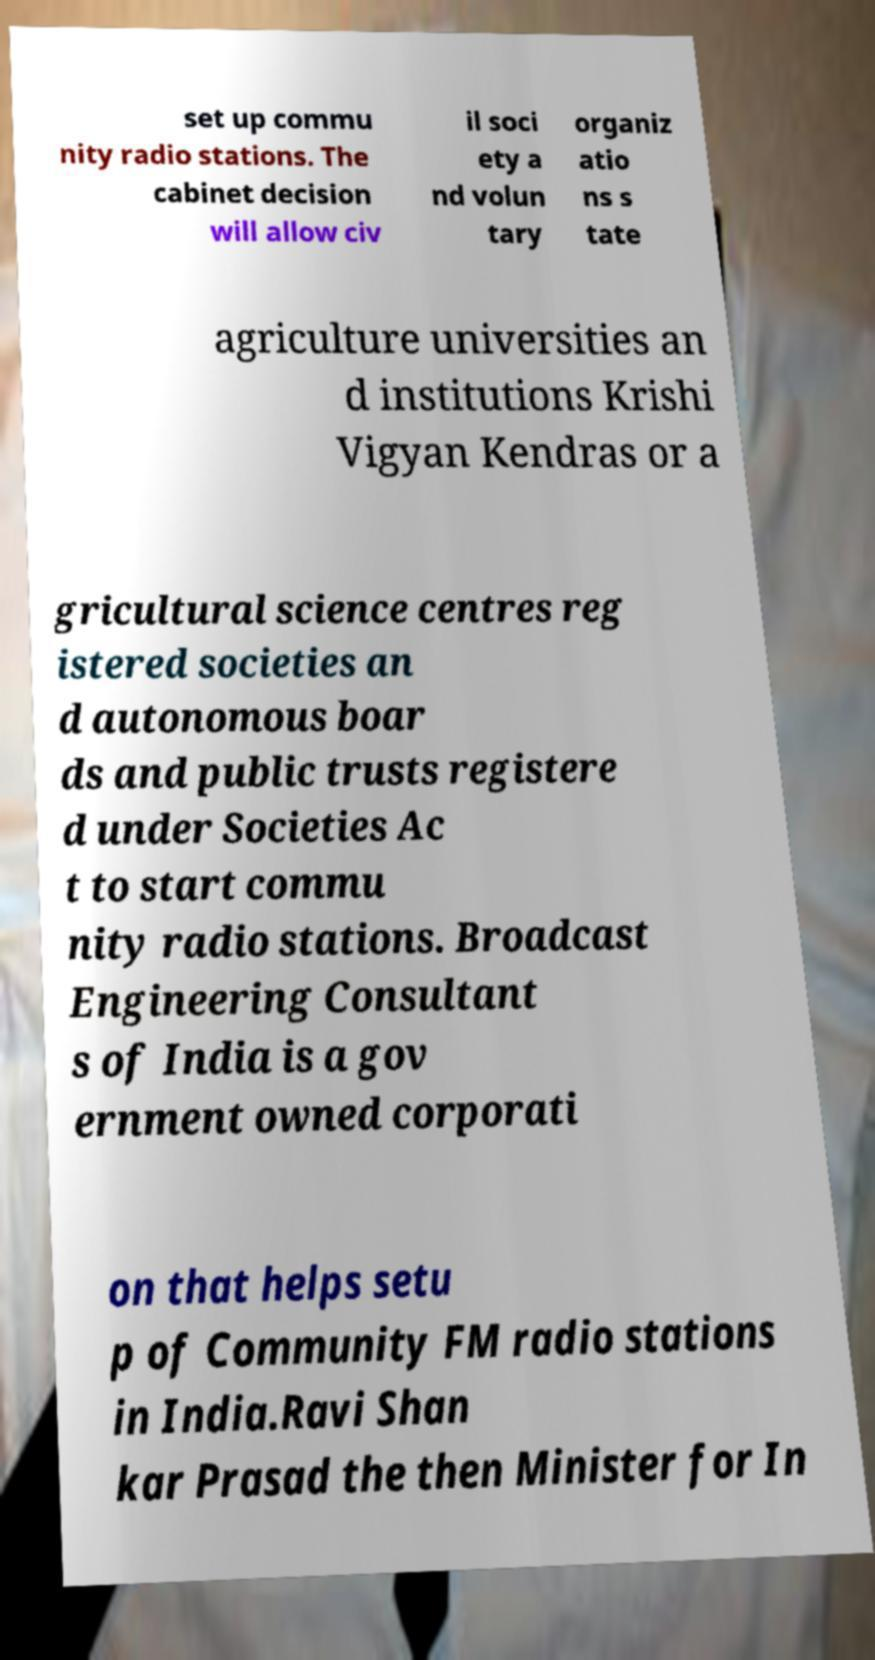Can you read and provide the text displayed in the image?This photo seems to have some interesting text. Can you extract and type it out for me? set up commu nity radio stations. The cabinet decision will allow civ il soci ety a nd volun tary organiz atio ns s tate agriculture universities an d institutions Krishi Vigyan Kendras or a gricultural science centres reg istered societies an d autonomous boar ds and public trusts registere d under Societies Ac t to start commu nity radio stations. Broadcast Engineering Consultant s of India is a gov ernment owned corporati on that helps setu p of Community FM radio stations in India.Ravi Shan kar Prasad the then Minister for In 